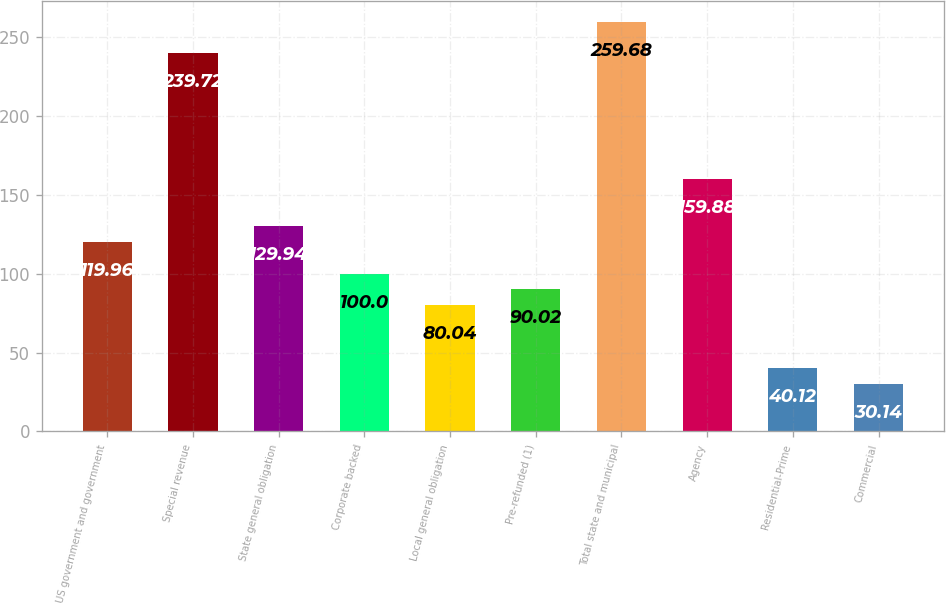Convert chart to OTSL. <chart><loc_0><loc_0><loc_500><loc_500><bar_chart><fcel>US government and government<fcel>Special revenue<fcel>State general obligation<fcel>Corporate backed<fcel>Local general obligation<fcel>Pre-refunded (1)<fcel>Total state and municipal<fcel>Agency<fcel>Residential-Prime<fcel>Commercial<nl><fcel>119.96<fcel>239.72<fcel>129.94<fcel>100<fcel>80.04<fcel>90.02<fcel>259.68<fcel>159.88<fcel>40.12<fcel>30.14<nl></chart> 